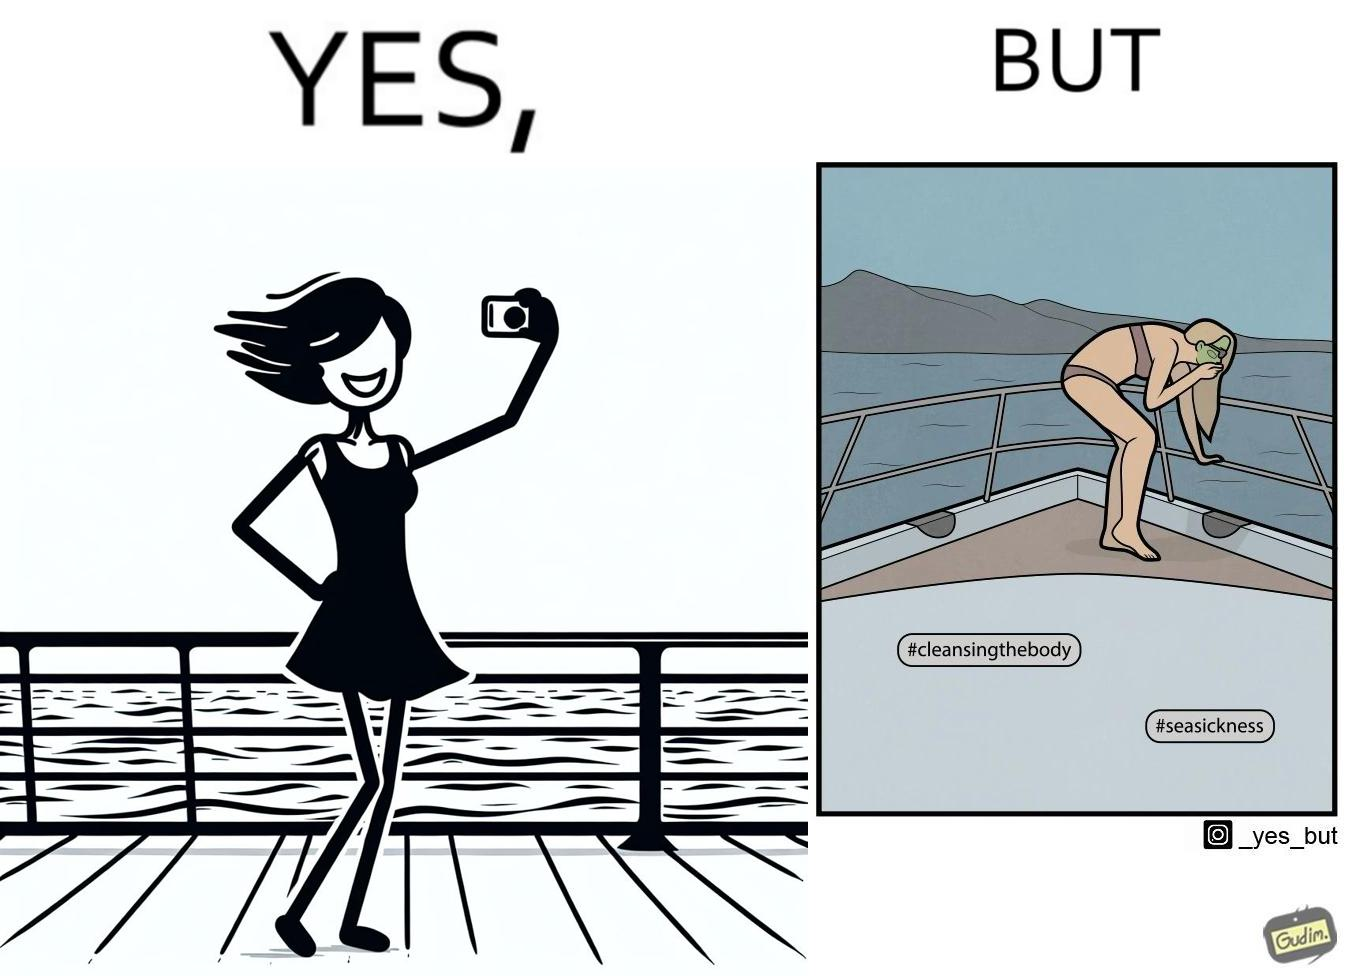Describe what you see in this image. The image is ironic, because in the first image the woman is showing how she is enjoying the sea trip but whereas the second image shows how she is struggling over the trip due to sea sickness which brings up a contrast comparison between the two photos 